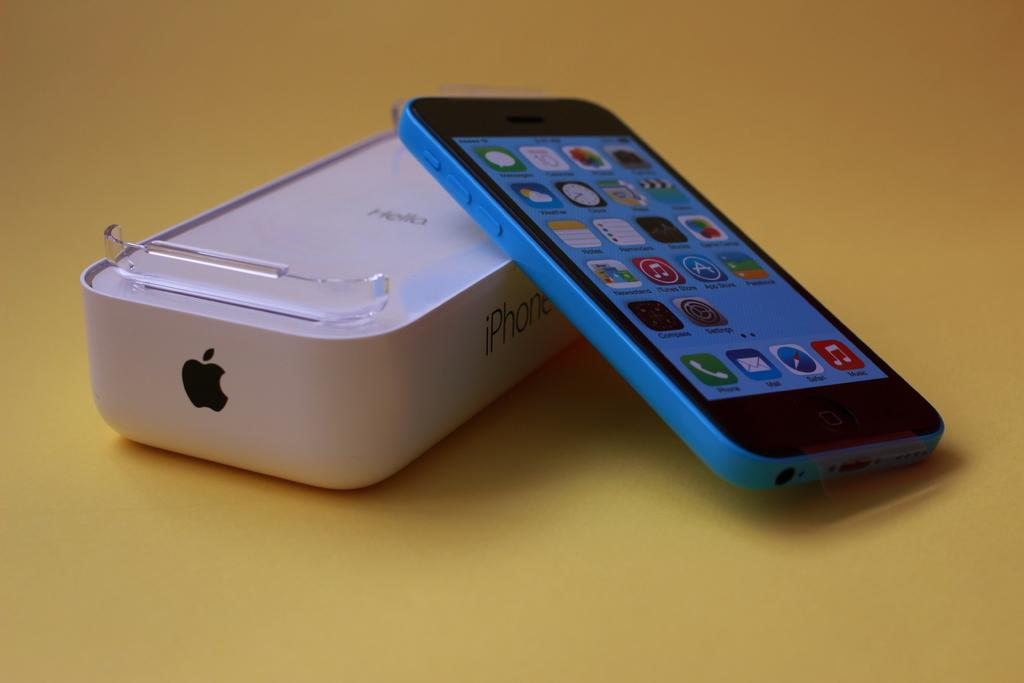Provide a one-sentence caption for the provided image. a phone with the word phone located on the phone icon. 